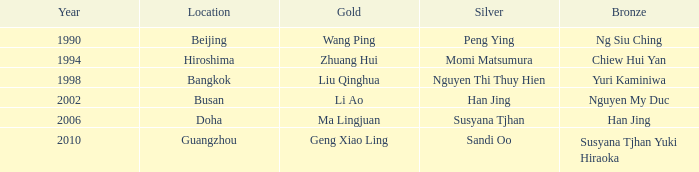What's the Bronze with the Year of 1998? Yuri Kaminiwa. 